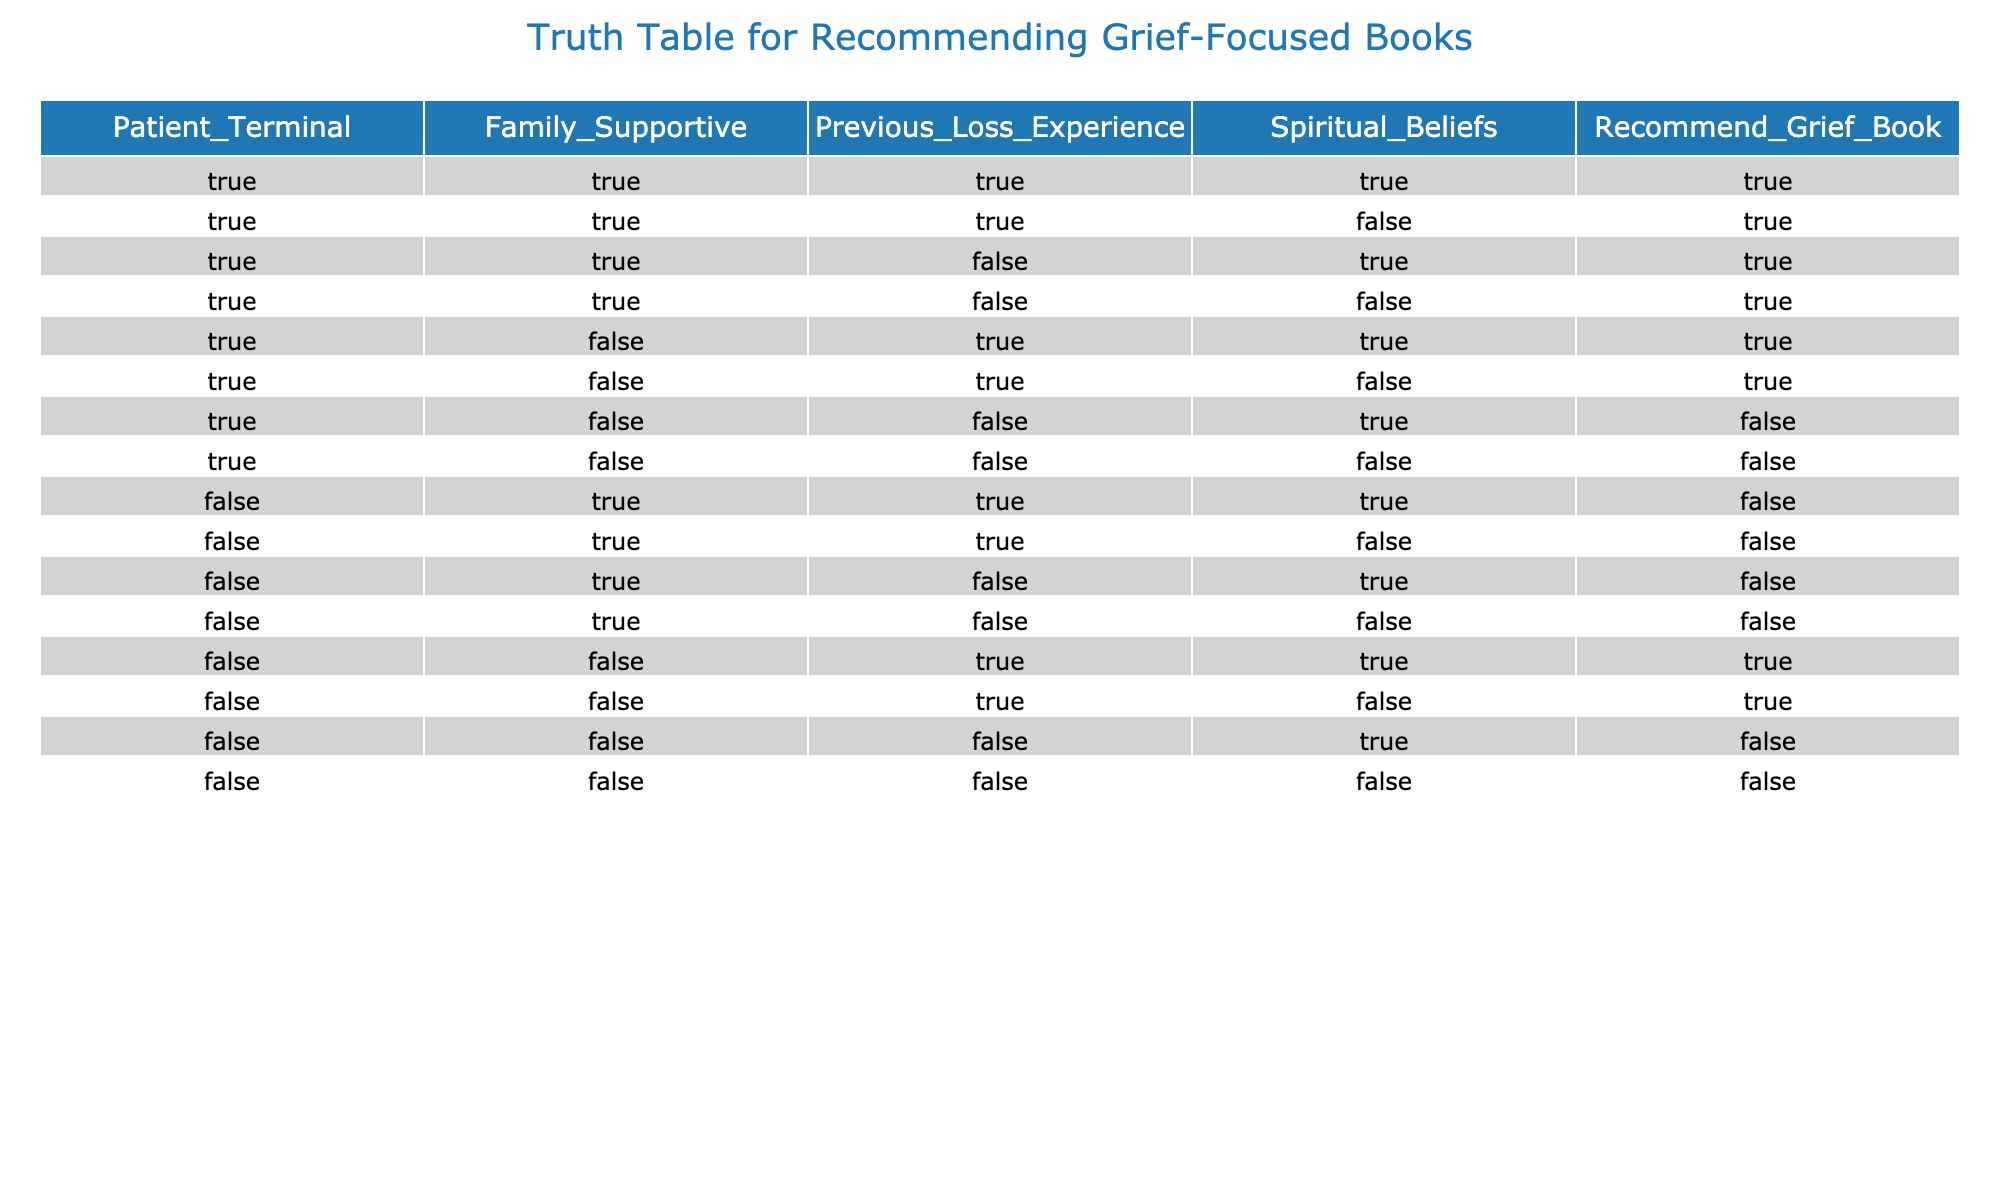What is the total number of recommendations for grief-focused books when the patient is terminal? There are a total of 8 rows where Patient_Terminal is True. In each of those cases, the Recommend_Grief_Book column shows that a book is recommended in all 8 instances.
Answer: 8 How many instances show that a grief-focused book is recommended when the family is supportive? To answer this, we must count the rows where Family_Supportive is True and Recommend_Grief_Book is also True. There are 5 such instances (rows with True under both columns) out of the total data set.
Answer: 5 Is a grief-focused book ever not recommended when the patient is terminal? Looking at the rows where Patient_Terminal is True and checking the Recommend_Grief_Book column, we see that there are two instances where a book is not recommended (False). One is when Family_Supportive is False and Previous_Loss_Experience is False and the other is when Previous_Loss_Experience is False and Spiritual_Beliefs is True.
Answer: Yes What is the relationship between previous loss experience and the recommendation of grief-focused books for terminal patients? For terminal patients (Patient_Terminal = True), we have 2 rows where Previous_Loss_Experience is False and the recommendation is made 4 times when it is True. This suggests that previous loss experience influences recommendations, as it is associated with a higher number of recommendations.
Answer: Positive relationship Do any patients without supportive families and without previous loss experience receive a recommendation for a grief-focused book? For the case where Patient_Terminal is True, there are rows with Family_Supportive as False and Previous_Loss_Experience as False which do not receive recommendations. Thus, there are no recommendations in such instances according to the data provided.
Answer: No 